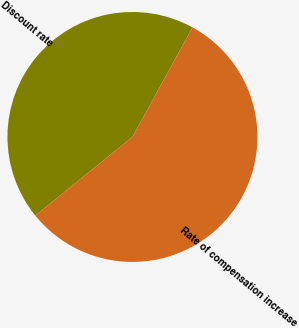<chart> <loc_0><loc_0><loc_500><loc_500><pie_chart><fcel>Discount rate<fcel>Rate of compensation increase<nl><fcel>43.82%<fcel>56.18%<nl></chart> 